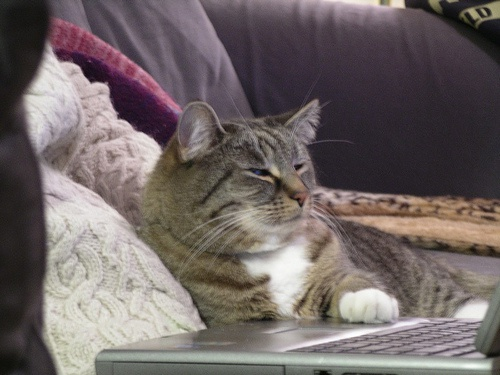Describe the objects in this image and their specific colors. I can see couch in black, gray, lightgray, and darkgray tones, cat in black, gray, and darkgray tones, and laptop in black, darkgray, gray, and lightgray tones in this image. 